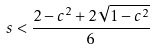Convert formula to latex. <formula><loc_0><loc_0><loc_500><loc_500>s < \frac { 2 - c ^ { 2 } + 2 \sqrt { 1 - c ^ { 2 } } } { 6 }</formula> 